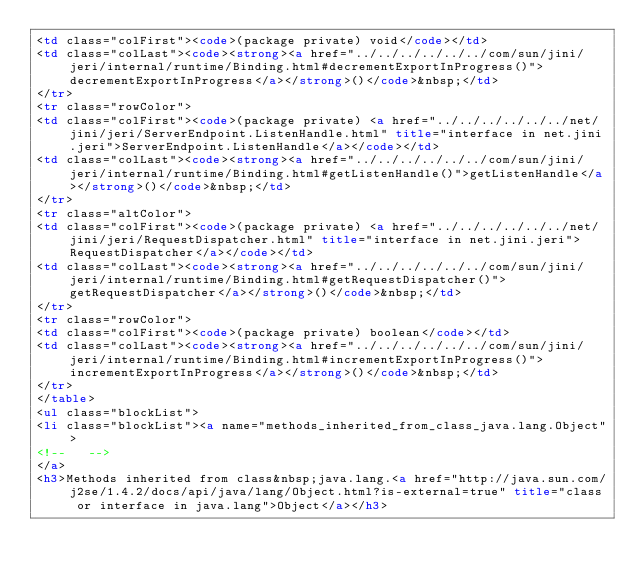Convert code to text. <code><loc_0><loc_0><loc_500><loc_500><_HTML_><td class="colFirst"><code>(package private) void</code></td>
<td class="colLast"><code><strong><a href="../../../../../../com/sun/jini/jeri/internal/runtime/Binding.html#decrementExportInProgress()">decrementExportInProgress</a></strong>()</code>&nbsp;</td>
</tr>
<tr class="rowColor">
<td class="colFirst"><code>(package private) <a href="../../../../../../net/jini/jeri/ServerEndpoint.ListenHandle.html" title="interface in net.jini.jeri">ServerEndpoint.ListenHandle</a></code></td>
<td class="colLast"><code><strong><a href="../../../../../../com/sun/jini/jeri/internal/runtime/Binding.html#getListenHandle()">getListenHandle</a></strong>()</code>&nbsp;</td>
</tr>
<tr class="altColor">
<td class="colFirst"><code>(package private) <a href="../../../../../../net/jini/jeri/RequestDispatcher.html" title="interface in net.jini.jeri">RequestDispatcher</a></code></td>
<td class="colLast"><code><strong><a href="../../../../../../com/sun/jini/jeri/internal/runtime/Binding.html#getRequestDispatcher()">getRequestDispatcher</a></strong>()</code>&nbsp;</td>
</tr>
<tr class="rowColor">
<td class="colFirst"><code>(package private) boolean</code></td>
<td class="colLast"><code><strong><a href="../../../../../../com/sun/jini/jeri/internal/runtime/Binding.html#incrementExportInProgress()">incrementExportInProgress</a></strong>()</code>&nbsp;</td>
</tr>
</table>
<ul class="blockList">
<li class="blockList"><a name="methods_inherited_from_class_java.lang.Object">
<!--   -->
</a>
<h3>Methods inherited from class&nbsp;java.lang.<a href="http://java.sun.com/j2se/1.4.2/docs/api/java/lang/Object.html?is-external=true" title="class or interface in java.lang">Object</a></h3></code> 